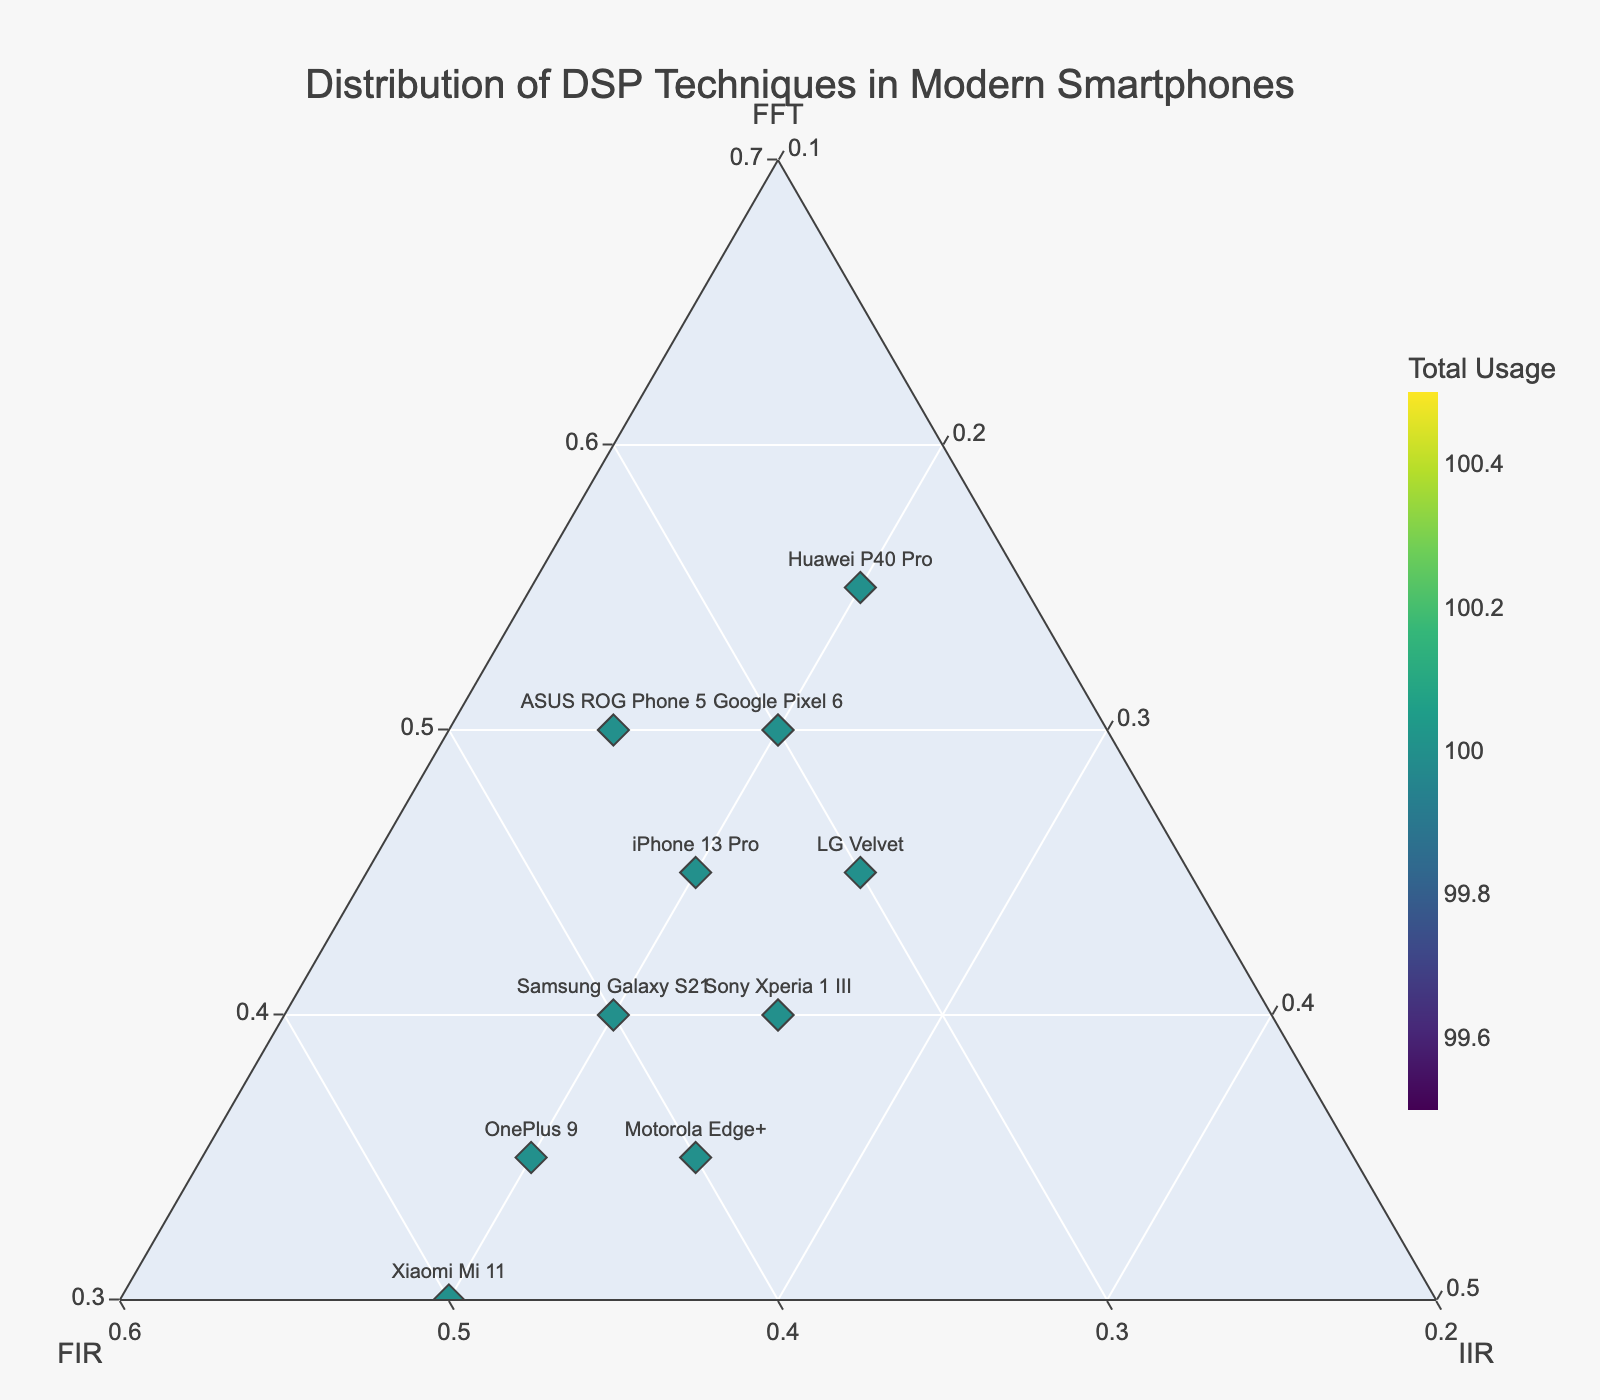What is the title of the figure? The title of the figure is usually the largest text and is located at the top of the figure. In this case, it details the primary subject of the visualization.
Answer: Distribution of DSP Techniques in Modern Smartphones Which smartphone uses the highest percentage of FFT? Locate the position on the ternary plot with the maximum value along the FFT axis. This point is annotated with the respective smartphone's name.
Answer: Huawei P40 Pro Which smartphone has the most balanced usage between FFT and FIR? Determine the point on the ternary plot that has nearly equal values for FFT and FIR while considering the total distribution.
Answer: Samsung Galaxy S21 How many smartphones have an IIR usage percentage equal to 20%? Identify and count the points on the ternary plot which have their c (IIR) value equal to 0.2 (20%).
Answer: 6 Which smartphone has the closest ratio of FIR to FFT? Observe the points to find the smartphone whose ratios of FFT and FIR are closest, usually through visual inspection of proximity along the diagonal between the FIR and FFT corners.
Answer: Samsung Galaxy S21 What is the total usage for the Google Pixel 6? Each point's color intensity is linked to its total usage. By finding the Google Pixel 6 marker and referring to the color bar, we determine the total. Alternatively, we can sum FFT + FIR + IIR for Google Pixel 6.
Answer: 100 Which smartphone has the lowest contribution from FIR? On the ternary plot, locate the point closest to the opposite side of the FIR axis. This position represents the lowest proportion of FIR for the corresponding smartphone.
Answer: Huawei P40 Pro Identify the smartphone with the second-highest percentage of FIR use. Compare the positions on the FIR axis to find which point has the second highest value for this axis.
Answer: Xiaomi Mi 11 How does the use of IIR compare across all smartphones? Observe the general distribution of data points across the ternary plot in relation to the IIR corner. Notice patterns or clusters that indicate IIR percentages.
Answer: Mostly, smartphones have IIR usage around 20%, with a few deviating slightly For OnePlus 9, what is the combined percentage usage of FFT and FIR? Add the percentages of FFT and FIR for OnePlus 9 directly from the ternary plot or the dataset.
Answer: 80 